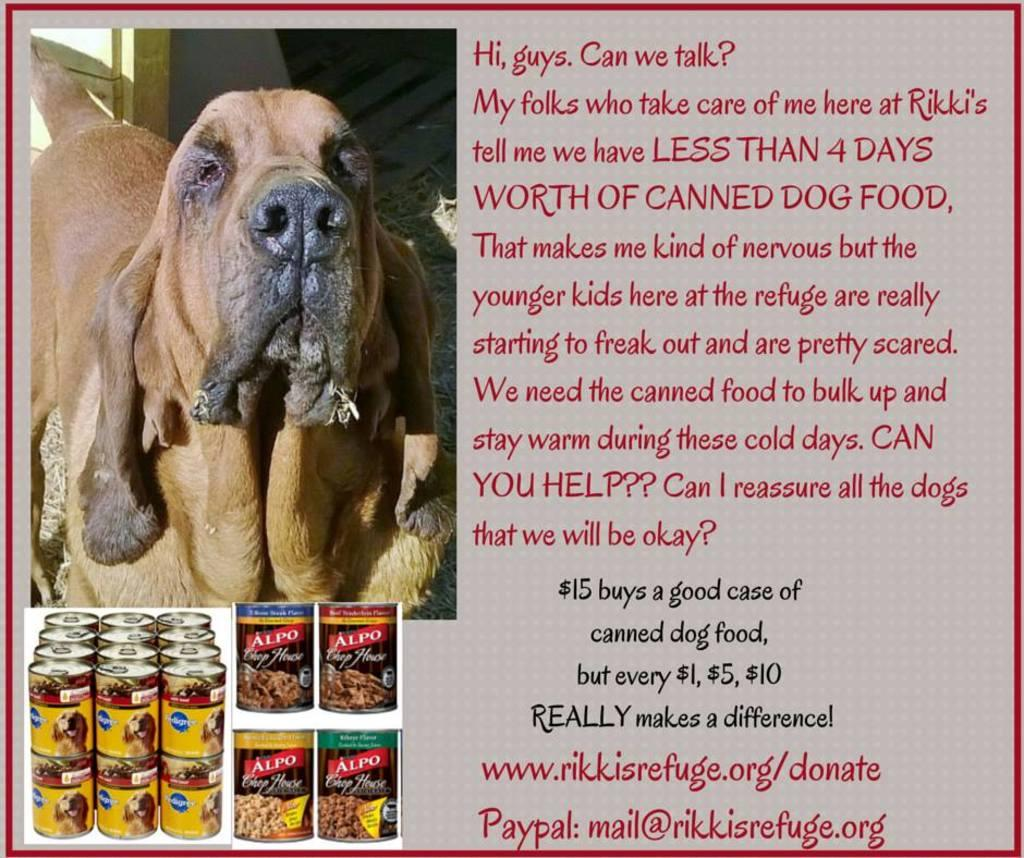What objects are present in the image? There are cans, a dog, and a wooden object in the image. What type of surface can be seen in the image? There is grass in the image. Where is the wooden object located in the image? The wooden object is on the left side of the image. What is written or displayed on the right side of the image? There is text and numbers on the right side of the image. What type of book is the dog reading in the image? There is no book present in the image, and the dog is not reading. 